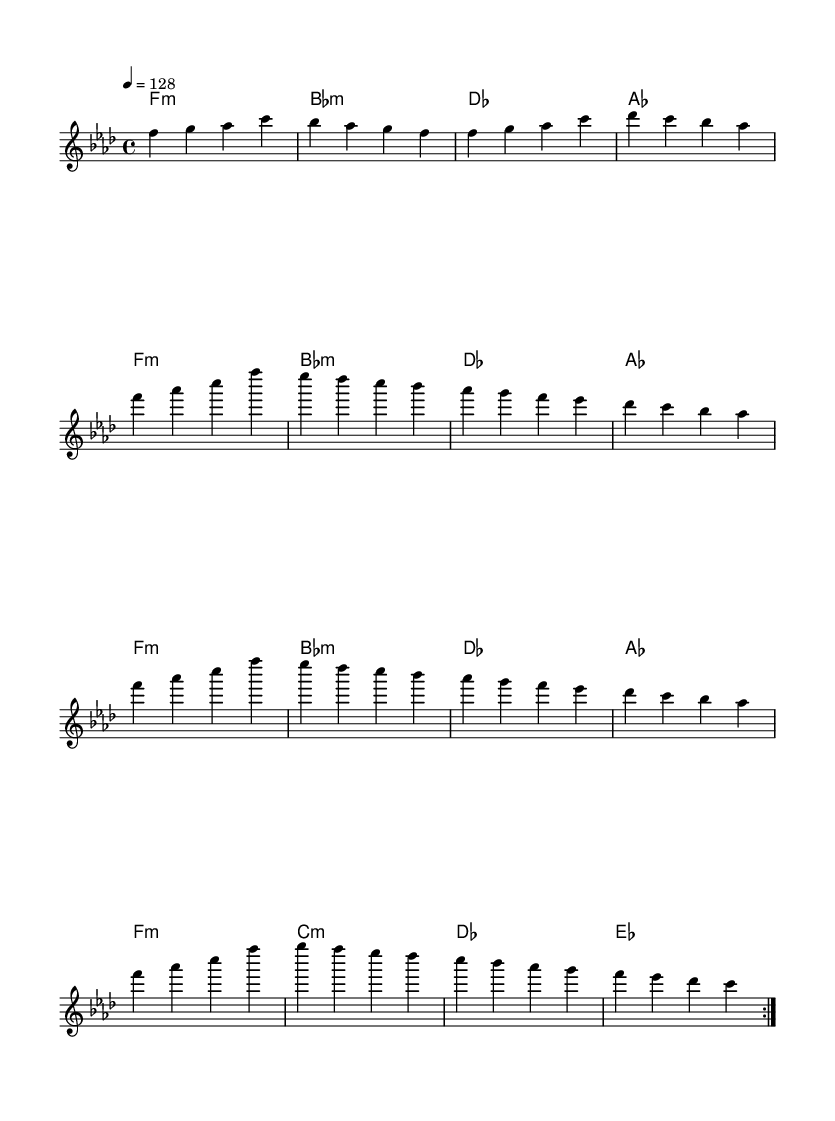What is the key signature of this music? The key signature shows two flats (B flat and E flat), indicating the piece is in F minor.
Answer: F minor What is the time signature of this music? The time signature appears at the beginning of the score, indicating it is in 4/4, which means there are four beats in each measure.
Answer: 4/4 What is the tempo marking for this piece? The tempo marking indicates a speed of quarter note equals 128 beats per minute, which gives a clear metric feel suitable for dance music.
Answer: 128 What is the first chord in the harmony section? The first chord in the harmony section is labeled as F minor, which is a triad formed by the notes F, A flat, and C.
Answer: F:m How many times does the melody repeat in the piece? The melody is marked to repeat two times, which allows for developing the theme and creating a sense of journey in the music.
Answer: 2 What is the structure of the melody in terms of phrases? Analyzing the melody, it consists of eight measures that develop four unique phrases, indicative of the overall structure of the piece.
Answer: 4 phrases What effect do the harmonies have in this dance piece? The harmonies using minor chords throughout create a rich, emotional sound that helps to elevate consciousness and enhance the overall dance experience.
Answer: Emotional sound 